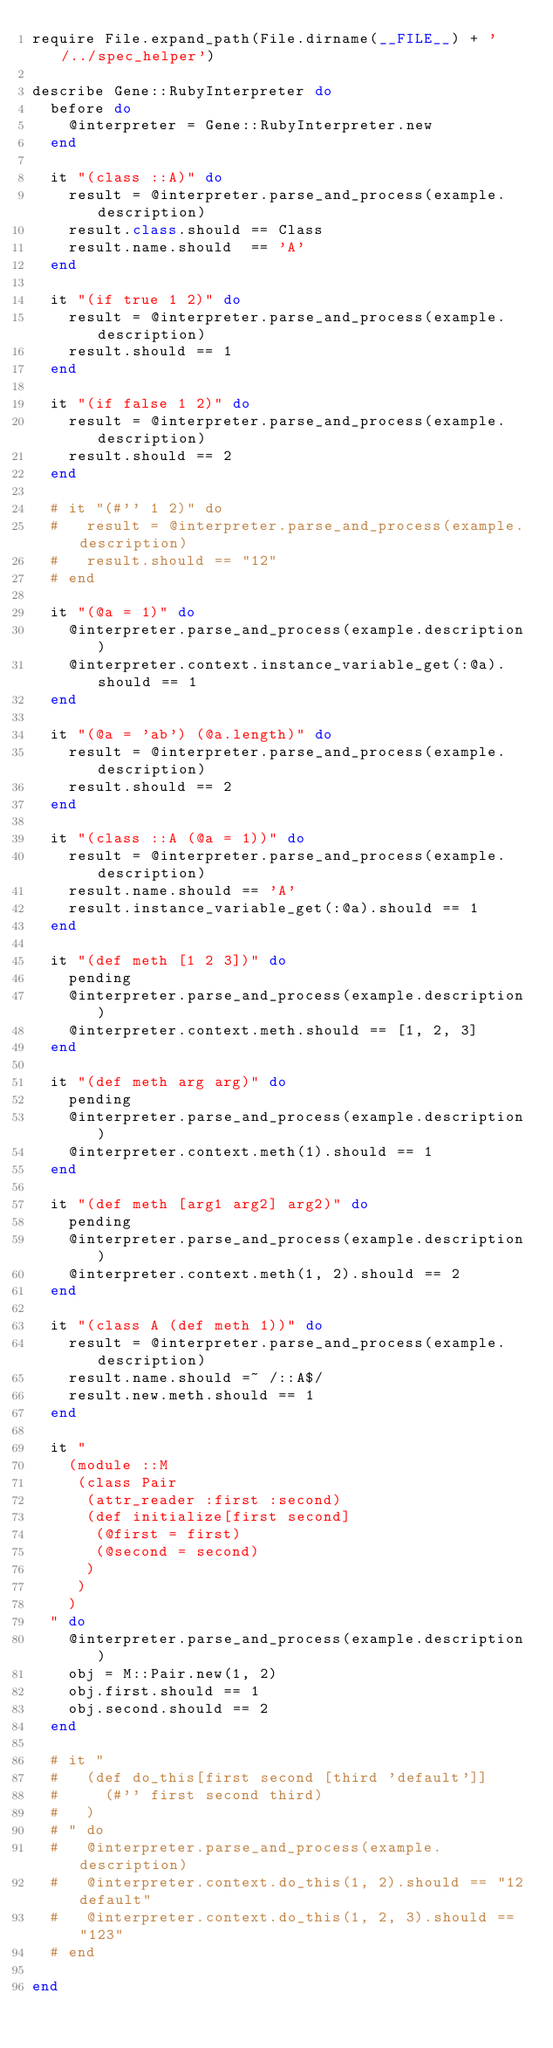<code> <loc_0><loc_0><loc_500><loc_500><_Ruby_>require File.expand_path(File.dirname(__FILE__) + '/../spec_helper')

describe Gene::RubyInterpreter do
  before do
    @interpreter = Gene::RubyInterpreter.new
  end

  it "(class ::A)" do
    result = @interpreter.parse_and_process(example.description)
    result.class.should == Class
    result.name.should  == 'A'
  end

  it "(if true 1 2)" do
    result = @interpreter.parse_and_process(example.description)
    result.should == 1
  end

  it "(if false 1 2)" do
    result = @interpreter.parse_and_process(example.description)
    result.should == 2
  end

  # it "(#'' 1 2)" do
  #   result = @interpreter.parse_and_process(example.description)
  #   result.should == "12"
  # end

  it "(@a = 1)" do
    @interpreter.parse_and_process(example.description)
    @interpreter.context.instance_variable_get(:@a).should == 1
  end

  it "(@a = 'ab') (@a.length)" do
    result = @interpreter.parse_and_process(example.description)
    result.should == 2
  end

  it "(class ::A (@a = 1))" do
    result = @interpreter.parse_and_process(example.description)
    result.name.should == 'A'
    result.instance_variable_get(:@a).should == 1
  end

  it "(def meth [1 2 3])" do
    pending
    @interpreter.parse_and_process(example.description)
    @interpreter.context.meth.should == [1, 2, 3]
  end

  it "(def meth arg arg)" do
    pending
    @interpreter.parse_and_process(example.description)
    @interpreter.context.meth(1).should == 1
  end

  it "(def meth [arg1 arg2] arg2)" do
    pending
    @interpreter.parse_and_process(example.description)
    @interpreter.context.meth(1, 2).should == 2
  end

  it "(class A (def meth 1))" do
    result = @interpreter.parse_and_process(example.description)
    result.name.should =~ /::A$/
    result.new.meth.should == 1
  end

  it "
    (module ::M
     (class Pair
      (attr_reader :first :second)
      (def initialize[first second]
       (@first = first)
       (@second = second)
      )
     )
    )
  " do
    @interpreter.parse_and_process(example.description)
    obj = M::Pair.new(1, 2)
    obj.first.should == 1
    obj.second.should == 2
  end

  # it "
  #   (def do_this[first second [third 'default']]
  #     (#'' first second third)
  #   )
  # " do
  #   @interpreter.parse_and_process(example.description)
  #   @interpreter.context.do_this(1, 2).should == "12default"
  #   @interpreter.context.do_this(1, 2, 3).should == "123"
  # end

end

</code> 